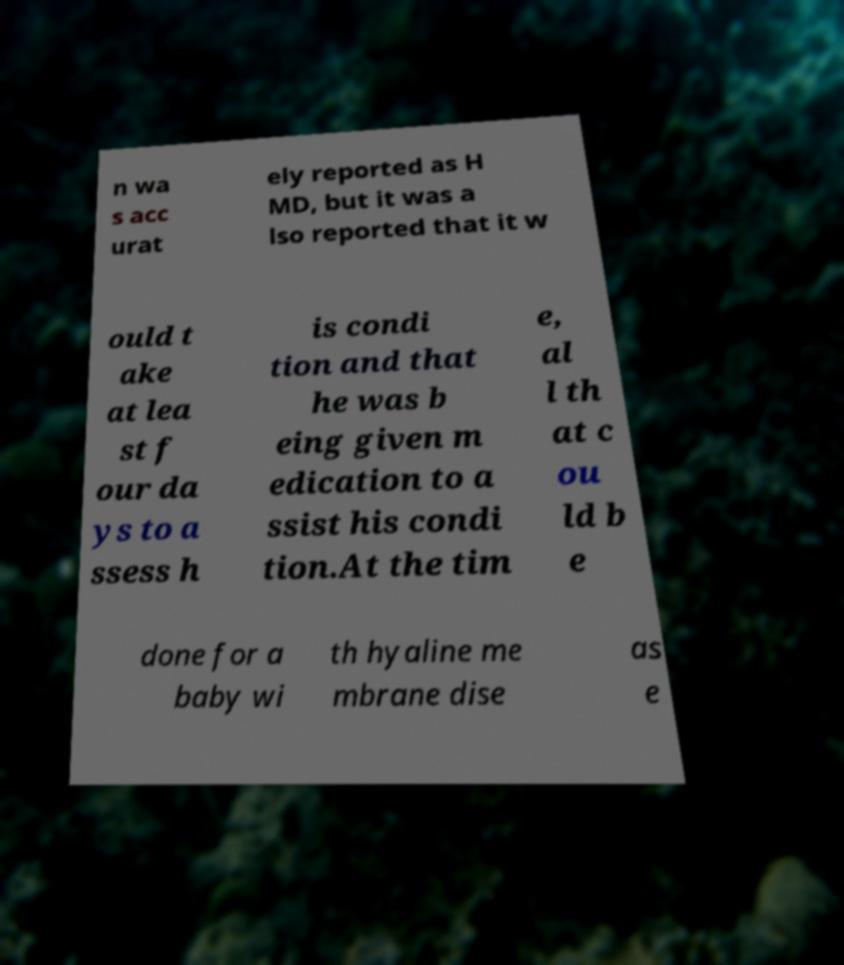I need the written content from this picture converted into text. Can you do that? n wa s acc urat ely reported as H MD, but it was a lso reported that it w ould t ake at lea st f our da ys to a ssess h is condi tion and that he was b eing given m edication to a ssist his condi tion.At the tim e, al l th at c ou ld b e done for a baby wi th hyaline me mbrane dise as e 